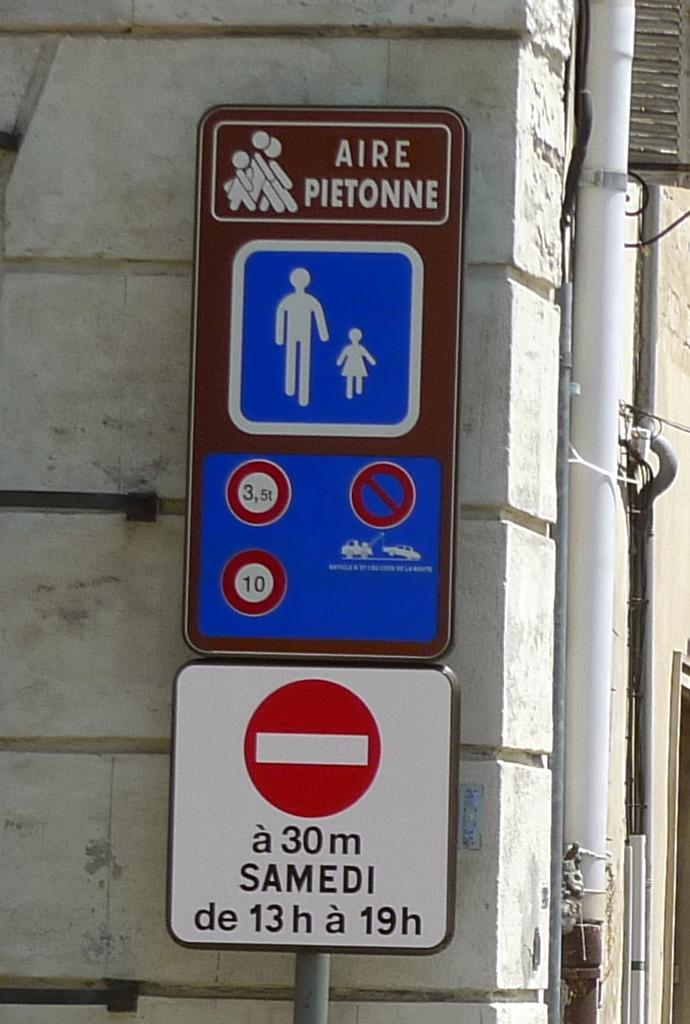<image>
Offer a succinct explanation of the picture presented. Signs are sitting next to a building with stating Aire Pietonne 